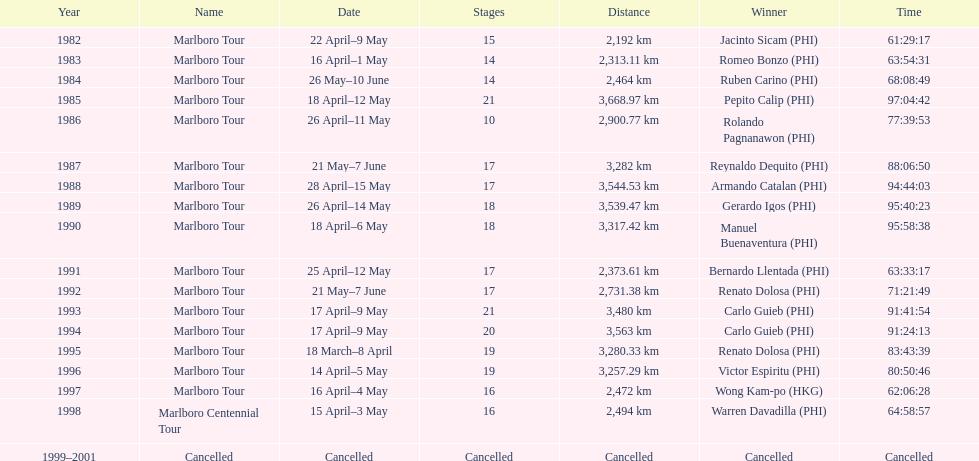Parse the full table. {'header': ['Year', 'Name', 'Date', 'Stages', 'Distance', 'Winner', 'Time'], 'rows': [['1982', 'Marlboro Tour', '22 April–9 May', '15', '2,192\xa0km', 'Jacinto Sicam\xa0(PHI)', '61:29:17'], ['1983', 'Marlboro Tour', '16 April–1 May', '14', '2,313.11\xa0km', 'Romeo Bonzo\xa0(PHI)', '63:54:31'], ['1984', 'Marlboro Tour', '26 May–10 June', '14', '2,464\xa0km', 'Ruben Carino\xa0(PHI)', '68:08:49'], ['1985', 'Marlboro Tour', '18 April–12 May', '21', '3,668.97\xa0km', 'Pepito Calip\xa0(PHI)', '97:04:42'], ['1986', 'Marlboro Tour', '26 April–11 May', '10', '2,900.77\xa0km', 'Rolando Pagnanawon\xa0(PHI)', '77:39:53'], ['1987', 'Marlboro Tour', '21 May–7 June', '17', '3,282\xa0km', 'Reynaldo Dequito\xa0(PHI)', '88:06:50'], ['1988', 'Marlboro Tour', '28 April–15 May', '17', '3,544.53\xa0km', 'Armando Catalan\xa0(PHI)', '94:44:03'], ['1989', 'Marlboro Tour', '26 April–14 May', '18', '3,539.47\xa0km', 'Gerardo Igos\xa0(PHI)', '95:40:23'], ['1990', 'Marlboro Tour', '18 April–6 May', '18', '3,317.42\xa0km', 'Manuel Buenaventura\xa0(PHI)', '95:58:38'], ['1991', 'Marlboro Tour', '25 April–12 May', '17', '2,373.61\xa0km', 'Bernardo Llentada\xa0(PHI)', '63:33:17'], ['1992', 'Marlboro Tour', '21 May–7 June', '17', '2,731.38\xa0km', 'Renato Dolosa\xa0(PHI)', '71:21:49'], ['1993', 'Marlboro Tour', '17 April–9 May', '21', '3,480\xa0km', 'Carlo Guieb\xa0(PHI)', '91:41:54'], ['1994', 'Marlboro Tour', '17 April–9 May', '20', '3,563\xa0km', 'Carlo Guieb\xa0(PHI)', '91:24:13'], ['1995', 'Marlboro Tour', '18 March–8 April', '19', '3,280.33\xa0km', 'Renato Dolosa\xa0(PHI)', '83:43:39'], ['1996', 'Marlboro Tour', '14 April–5 May', '19', '3,257.29\xa0km', 'Victor Espiritu\xa0(PHI)', '80:50:46'], ['1997', 'Marlboro Tour', '16 April–4 May', '16', '2,472\xa0km', 'Wong Kam-po\xa0(HKG)', '62:06:28'], ['1998', 'Marlboro Centennial Tour', '15 April–3 May', '16', '2,494\xa0km', 'Warren Davadilla\xa0(PHI)', '64:58:57'], ['1999–2001', 'Cancelled', 'Cancelled', 'Cancelled', 'Cancelled', 'Cancelled', 'Cancelled']]} Who is listed below romeo bonzo? Ruben Carino (PHI). 